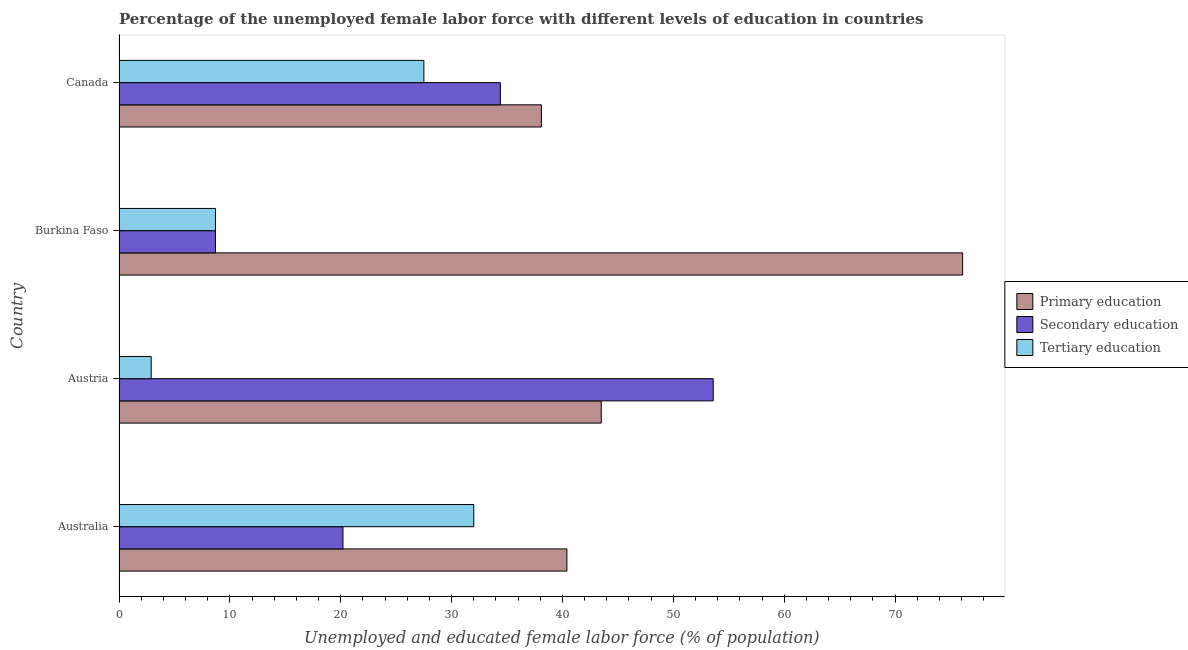How many groups of bars are there?
Keep it short and to the point. 4. Are the number of bars on each tick of the Y-axis equal?
Ensure brevity in your answer.  Yes. How many bars are there on the 2nd tick from the top?
Make the answer very short. 3. What is the label of the 2nd group of bars from the top?
Offer a very short reply. Burkina Faso. What is the percentage of female labor force who received primary education in Austria?
Offer a very short reply. 43.5. Across all countries, what is the maximum percentage of female labor force who received tertiary education?
Make the answer very short. 32. Across all countries, what is the minimum percentage of female labor force who received tertiary education?
Provide a succinct answer. 2.9. In which country was the percentage of female labor force who received secondary education minimum?
Your answer should be compact. Burkina Faso. What is the total percentage of female labor force who received primary education in the graph?
Provide a succinct answer. 198.1. What is the difference between the percentage of female labor force who received tertiary education in Australia and that in Canada?
Provide a short and direct response. 4.5. What is the difference between the percentage of female labor force who received secondary education in Canada and the percentage of female labor force who received primary education in Burkina Faso?
Offer a very short reply. -41.7. What is the average percentage of female labor force who received primary education per country?
Provide a short and direct response. 49.52. What is the difference between the percentage of female labor force who received secondary education and percentage of female labor force who received primary education in Canada?
Offer a terse response. -3.7. In how many countries, is the percentage of female labor force who received secondary education greater than 14 %?
Keep it short and to the point. 3. What is the ratio of the percentage of female labor force who received tertiary education in Australia to that in Austria?
Keep it short and to the point. 11.03. What is the difference between the highest and the second highest percentage of female labor force who received secondary education?
Offer a very short reply. 19.2. What is the difference between the highest and the lowest percentage of female labor force who received tertiary education?
Ensure brevity in your answer.  29.1. Is the sum of the percentage of female labor force who received secondary education in Australia and Canada greater than the maximum percentage of female labor force who received tertiary education across all countries?
Your response must be concise. Yes. What does the 2nd bar from the top in Burkina Faso represents?
Provide a succinct answer. Secondary education. What does the 3rd bar from the bottom in Austria represents?
Make the answer very short. Tertiary education. Is it the case that in every country, the sum of the percentage of female labor force who received primary education and percentage of female labor force who received secondary education is greater than the percentage of female labor force who received tertiary education?
Provide a succinct answer. Yes. How many countries are there in the graph?
Keep it short and to the point. 4. Are the values on the major ticks of X-axis written in scientific E-notation?
Provide a short and direct response. No. Does the graph contain grids?
Give a very brief answer. No. Where does the legend appear in the graph?
Make the answer very short. Center right. How many legend labels are there?
Your answer should be compact. 3. How are the legend labels stacked?
Keep it short and to the point. Vertical. What is the title of the graph?
Provide a short and direct response. Percentage of the unemployed female labor force with different levels of education in countries. Does "Capital account" appear as one of the legend labels in the graph?
Your response must be concise. No. What is the label or title of the X-axis?
Your answer should be compact. Unemployed and educated female labor force (% of population). What is the label or title of the Y-axis?
Your answer should be very brief. Country. What is the Unemployed and educated female labor force (% of population) of Primary education in Australia?
Ensure brevity in your answer.  40.4. What is the Unemployed and educated female labor force (% of population) of Secondary education in Australia?
Offer a very short reply. 20.2. What is the Unemployed and educated female labor force (% of population) in Primary education in Austria?
Your answer should be compact. 43.5. What is the Unemployed and educated female labor force (% of population) of Secondary education in Austria?
Offer a very short reply. 53.6. What is the Unemployed and educated female labor force (% of population) in Tertiary education in Austria?
Your response must be concise. 2.9. What is the Unemployed and educated female labor force (% of population) in Primary education in Burkina Faso?
Your answer should be compact. 76.1. What is the Unemployed and educated female labor force (% of population) of Secondary education in Burkina Faso?
Make the answer very short. 8.7. What is the Unemployed and educated female labor force (% of population) in Tertiary education in Burkina Faso?
Provide a short and direct response. 8.7. What is the Unemployed and educated female labor force (% of population) in Primary education in Canada?
Your answer should be very brief. 38.1. What is the Unemployed and educated female labor force (% of population) in Secondary education in Canada?
Your answer should be compact. 34.4. What is the Unemployed and educated female labor force (% of population) in Tertiary education in Canada?
Offer a terse response. 27.5. Across all countries, what is the maximum Unemployed and educated female labor force (% of population) of Primary education?
Offer a very short reply. 76.1. Across all countries, what is the maximum Unemployed and educated female labor force (% of population) in Secondary education?
Provide a short and direct response. 53.6. Across all countries, what is the minimum Unemployed and educated female labor force (% of population) of Primary education?
Offer a very short reply. 38.1. Across all countries, what is the minimum Unemployed and educated female labor force (% of population) of Secondary education?
Keep it short and to the point. 8.7. Across all countries, what is the minimum Unemployed and educated female labor force (% of population) in Tertiary education?
Ensure brevity in your answer.  2.9. What is the total Unemployed and educated female labor force (% of population) of Primary education in the graph?
Offer a very short reply. 198.1. What is the total Unemployed and educated female labor force (% of population) of Secondary education in the graph?
Give a very brief answer. 116.9. What is the total Unemployed and educated female labor force (% of population) of Tertiary education in the graph?
Your answer should be very brief. 71.1. What is the difference between the Unemployed and educated female labor force (% of population) in Secondary education in Australia and that in Austria?
Make the answer very short. -33.4. What is the difference between the Unemployed and educated female labor force (% of population) of Tertiary education in Australia and that in Austria?
Your answer should be very brief. 29.1. What is the difference between the Unemployed and educated female labor force (% of population) of Primary education in Australia and that in Burkina Faso?
Your answer should be very brief. -35.7. What is the difference between the Unemployed and educated female labor force (% of population) of Tertiary education in Australia and that in Burkina Faso?
Offer a terse response. 23.3. What is the difference between the Unemployed and educated female labor force (% of population) of Secondary education in Australia and that in Canada?
Ensure brevity in your answer.  -14.2. What is the difference between the Unemployed and educated female labor force (% of population) in Tertiary education in Australia and that in Canada?
Ensure brevity in your answer.  4.5. What is the difference between the Unemployed and educated female labor force (% of population) in Primary education in Austria and that in Burkina Faso?
Your answer should be compact. -32.6. What is the difference between the Unemployed and educated female labor force (% of population) of Secondary education in Austria and that in Burkina Faso?
Your answer should be compact. 44.9. What is the difference between the Unemployed and educated female labor force (% of population) in Secondary education in Austria and that in Canada?
Your answer should be very brief. 19.2. What is the difference between the Unemployed and educated female labor force (% of population) in Tertiary education in Austria and that in Canada?
Offer a terse response. -24.6. What is the difference between the Unemployed and educated female labor force (% of population) of Primary education in Burkina Faso and that in Canada?
Provide a short and direct response. 38. What is the difference between the Unemployed and educated female labor force (% of population) in Secondary education in Burkina Faso and that in Canada?
Your answer should be very brief. -25.7. What is the difference between the Unemployed and educated female labor force (% of population) of Tertiary education in Burkina Faso and that in Canada?
Make the answer very short. -18.8. What is the difference between the Unemployed and educated female labor force (% of population) in Primary education in Australia and the Unemployed and educated female labor force (% of population) in Tertiary education in Austria?
Your answer should be very brief. 37.5. What is the difference between the Unemployed and educated female labor force (% of population) in Primary education in Australia and the Unemployed and educated female labor force (% of population) in Secondary education in Burkina Faso?
Your answer should be very brief. 31.7. What is the difference between the Unemployed and educated female labor force (% of population) in Primary education in Australia and the Unemployed and educated female labor force (% of population) in Tertiary education in Burkina Faso?
Ensure brevity in your answer.  31.7. What is the difference between the Unemployed and educated female labor force (% of population) of Secondary education in Australia and the Unemployed and educated female labor force (% of population) of Tertiary education in Burkina Faso?
Ensure brevity in your answer.  11.5. What is the difference between the Unemployed and educated female labor force (% of population) in Primary education in Australia and the Unemployed and educated female labor force (% of population) in Tertiary education in Canada?
Your answer should be compact. 12.9. What is the difference between the Unemployed and educated female labor force (% of population) in Primary education in Austria and the Unemployed and educated female labor force (% of population) in Secondary education in Burkina Faso?
Provide a short and direct response. 34.8. What is the difference between the Unemployed and educated female labor force (% of population) of Primary education in Austria and the Unemployed and educated female labor force (% of population) of Tertiary education in Burkina Faso?
Keep it short and to the point. 34.8. What is the difference between the Unemployed and educated female labor force (% of population) of Secondary education in Austria and the Unemployed and educated female labor force (% of population) of Tertiary education in Burkina Faso?
Keep it short and to the point. 44.9. What is the difference between the Unemployed and educated female labor force (% of population) in Primary education in Austria and the Unemployed and educated female labor force (% of population) in Tertiary education in Canada?
Provide a short and direct response. 16. What is the difference between the Unemployed and educated female labor force (% of population) in Secondary education in Austria and the Unemployed and educated female labor force (% of population) in Tertiary education in Canada?
Offer a terse response. 26.1. What is the difference between the Unemployed and educated female labor force (% of population) in Primary education in Burkina Faso and the Unemployed and educated female labor force (% of population) in Secondary education in Canada?
Give a very brief answer. 41.7. What is the difference between the Unemployed and educated female labor force (% of population) in Primary education in Burkina Faso and the Unemployed and educated female labor force (% of population) in Tertiary education in Canada?
Make the answer very short. 48.6. What is the difference between the Unemployed and educated female labor force (% of population) in Secondary education in Burkina Faso and the Unemployed and educated female labor force (% of population) in Tertiary education in Canada?
Your answer should be compact. -18.8. What is the average Unemployed and educated female labor force (% of population) in Primary education per country?
Keep it short and to the point. 49.52. What is the average Unemployed and educated female labor force (% of population) of Secondary education per country?
Offer a terse response. 29.23. What is the average Unemployed and educated female labor force (% of population) in Tertiary education per country?
Provide a short and direct response. 17.77. What is the difference between the Unemployed and educated female labor force (% of population) of Primary education and Unemployed and educated female labor force (% of population) of Secondary education in Australia?
Your answer should be very brief. 20.2. What is the difference between the Unemployed and educated female labor force (% of population) in Secondary education and Unemployed and educated female labor force (% of population) in Tertiary education in Australia?
Offer a terse response. -11.8. What is the difference between the Unemployed and educated female labor force (% of population) of Primary education and Unemployed and educated female labor force (% of population) of Secondary education in Austria?
Offer a terse response. -10.1. What is the difference between the Unemployed and educated female labor force (% of population) in Primary education and Unemployed and educated female labor force (% of population) in Tertiary education in Austria?
Offer a very short reply. 40.6. What is the difference between the Unemployed and educated female labor force (% of population) in Secondary education and Unemployed and educated female labor force (% of population) in Tertiary education in Austria?
Provide a succinct answer. 50.7. What is the difference between the Unemployed and educated female labor force (% of population) in Primary education and Unemployed and educated female labor force (% of population) in Secondary education in Burkina Faso?
Provide a short and direct response. 67.4. What is the difference between the Unemployed and educated female labor force (% of population) of Primary education and Unemployed and educated female labor force (% of population) of Tertiary education in Burkina Faso?
Provide a short and direct response. 67.4. What is the ratio of the Unemployed and educated female labor force (% of population) in Primary education in Australia to that in Austria?
Make the answer very short. 0.93. What is the ratio of the Unemployed and educated female labor force (% of population) in Secondary education in Australia to that in Austria?
Your answer should be compact. 0.38. What is the ratio of the Unemployed and educated female labor force (% of population) in Tertiary education in Australia to that in Austria?
Ensure brevity in your answer.  11.03. What is the ratio of the Unemployed and educated female labor force (% of population) of Primary education in Australia to that in Burkina Faso?
Offer a very short reply. 0.53. What is the ratio of the Unemployed and educated female labor force (% of population) of Secondary education in Australia to that in Burkina Faso?
Provide a short and direct response. 2.32. What is the ratio of the Unemployed and educated female labor force (% of population) in Tertiary education in Australia to that in Burkina Faso?
Give a very brief answer. 3.68. What is the ratio of the Unemployed and educated female labor force (% of population) in Primary education in Australia to that in Canada?
Offer a terse response. 1.06. What is the ratio of the Unemployed and educated female labor force (% of population) in Secondary education in Australia to that in Canada?
Offer a very short reply. 0.59. What is the ratio of the Unemployed and educated female labor force (% of population) in Tertiary education in Australia to that in Canada?
Make the answer very short. 1.16. What is the ratio of the Unemployed and educated female labor force (% of population) of Primary education in Austria to that in Burkina Faso?
Ensure brevity in your answer.  0.57. What is the ratio of the Unemployed and educated female labor force (% of population) in Secondary education in Austria to that in Burkina Faso?
Offer a terse response. 6.16. What is the ratio of the Unemployed and educated female labor force (% of population) in Tertiary education in Austria to that in Burkina Faso?
Offer a very short reply. 0.33. What is the ratio of the Unemployed and educated female labor force (% of population) of Primary education in Austria to that in Canada?
Your answer should be compact. 1.14. What is the ratio of the Unemployed and educated female labor force (% of population) of Secondary education in Austria to that in Canada?
Your answer should be very brief. 1.56. What is the ratio of the Unemployed and educated female labor force (% of population) in Tertiary education in Austria to that in Canada?
Provide a short and direct response. 0.11. What is the ratio of the Unemployed and educated female labor force (% of population) of Primary education in Burkina Faso to that in Canada?
Provide a short and direct response. 2. What is the ratio of the Unemployed and educated female labor force (% of population) in Secondary education in Burkina Faso to that in Canada?
Ensure brevity in your answer.  0.25. What is the ratio of the Unemployed and educated female labor force (% of population) of Tertiary education in Burkina Faso to that in Canada?
Provide a short and direct response. 0.32. What is the difference between the highest and the second highest Unemployed and educated female labor force (% of population) of Primary education?
Provide a succinct answer. 32.6. What is the difference between the highest and the second highest Unemployed and educated female labor force (% of population) in Secondary education?
Your response must be concise. 19.2. What is the difference between the highest and the second highest Unemployed and educated female labor force (% of population) in Tertiary education?
Provide a short and direct response. 4.5. What is the difference between the highest and the lowest Unemployed and educated female labor force (% of population) of Secondary education?
Make the answer very short. 44.9. What is the difference between the highest and the lowest Unemployed and educated female labor force (% of population) of Tertiary education?
Provide a short and direct response. 29.1. 